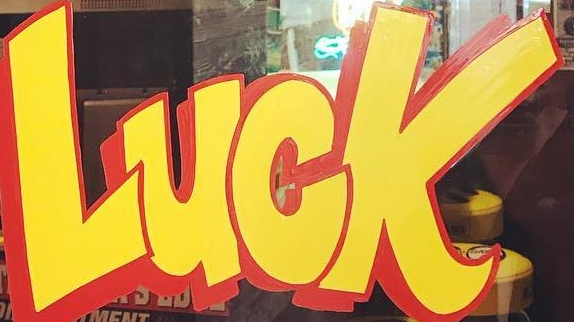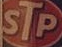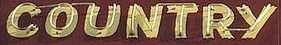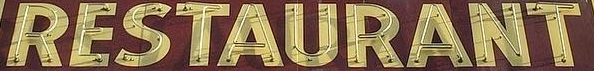What words can you see in these images in sequence, separated by a semicolon? LUCK; STP; COUNTRY; RESTAURANT 